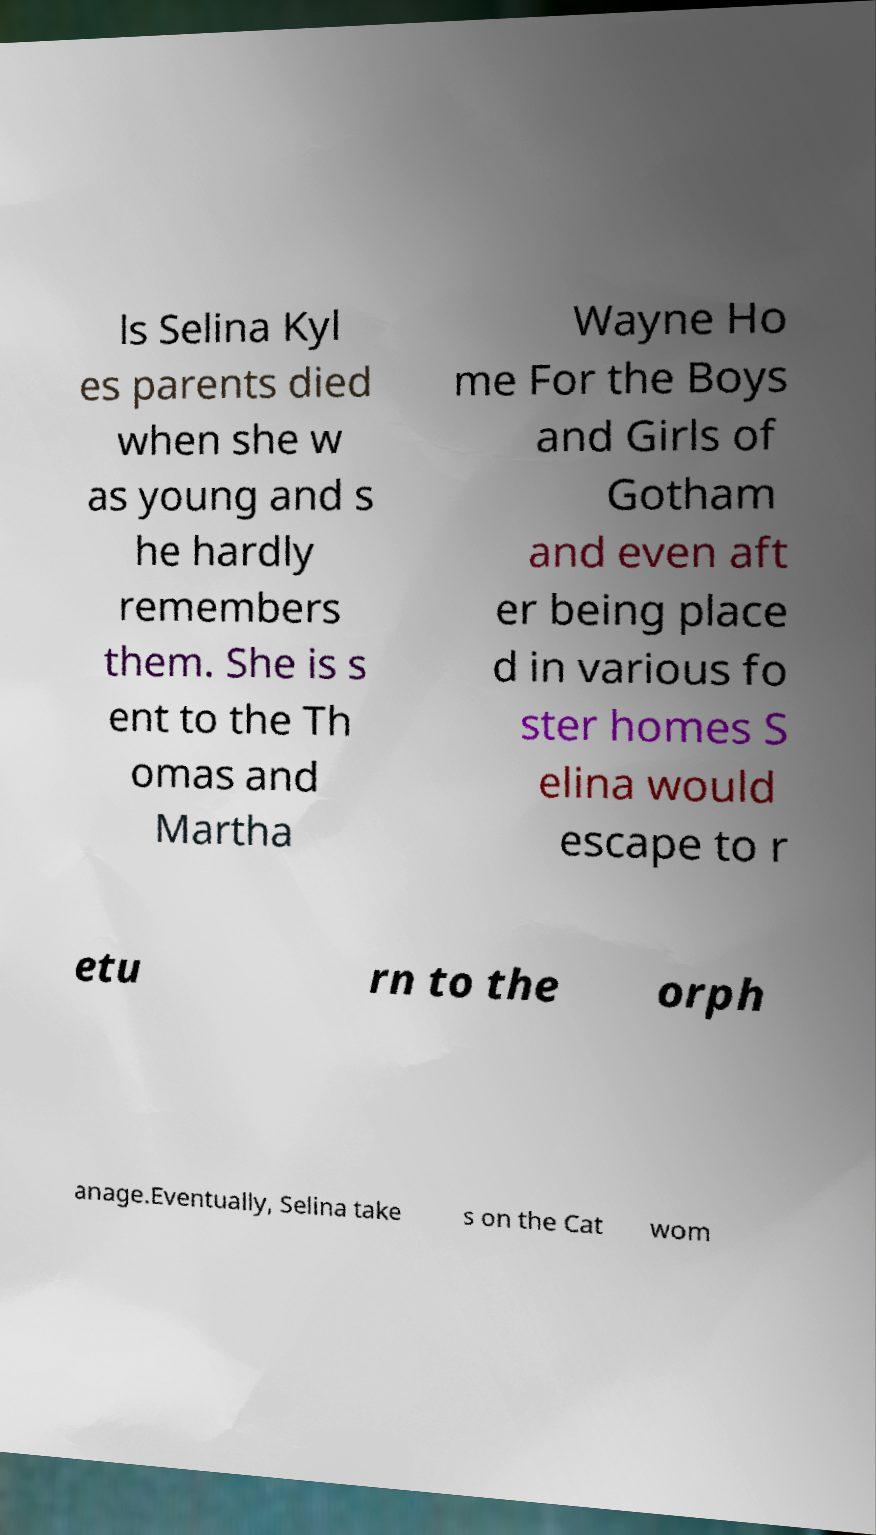Please read and relay the text visible in this image. What does it say? ls Selina Kyl es parents died when she w as young and s he hardly remembers them. She is s ent to the Th omas and Martha Wayne Ho me For the Boys and Girls of Gotham and even aft er being place d in various fo ster homes S elina would escape to r etu rn to the orph anage.Eventually, Selina take s on the Cat wom 